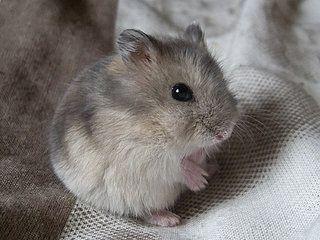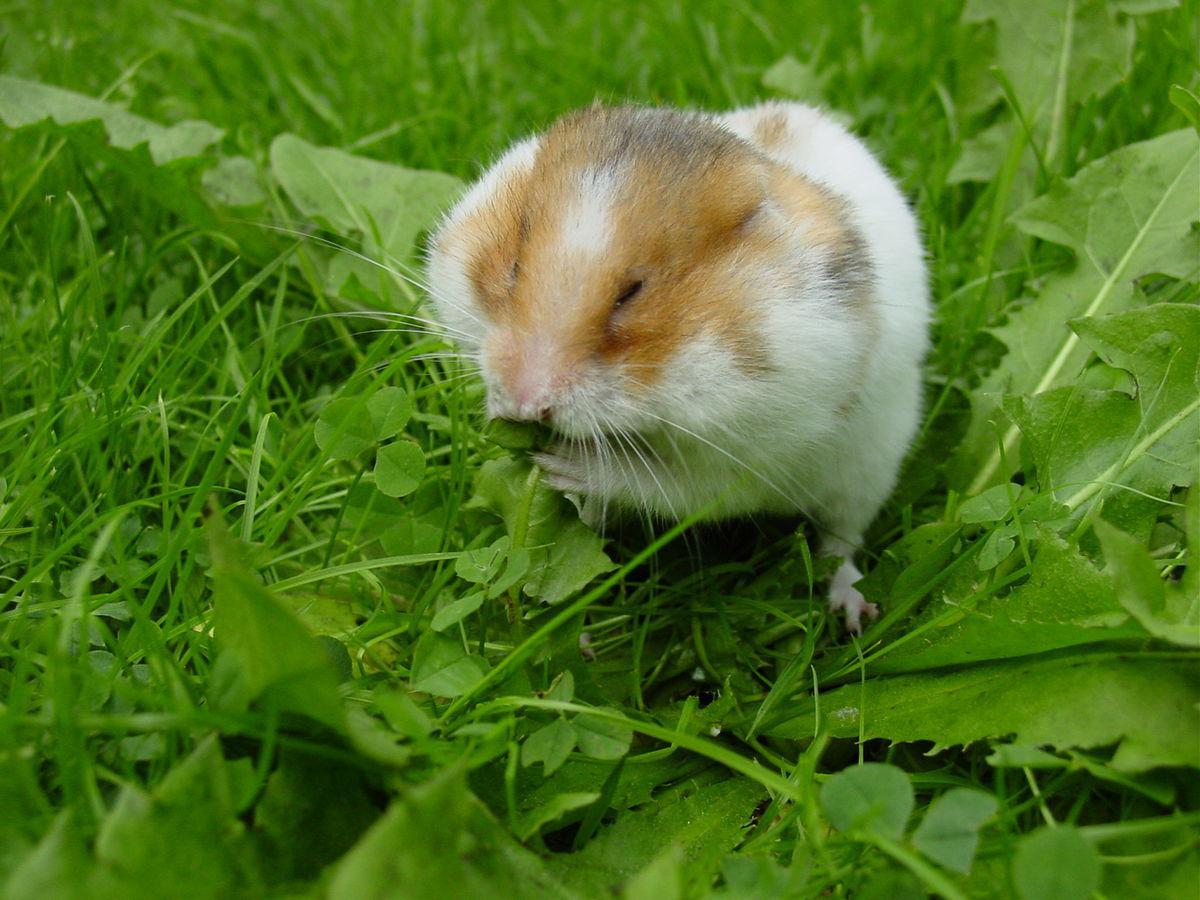The first image is the image on the left, the second image is the image on the right. For the images shown, is this caption "The rodent-type pet in the right image is on a green backdrop." true? Answer yes or no. Yes. 